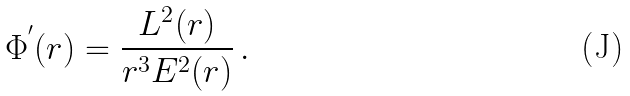<formula> <loc_0><loc_0><loc_500><loc_500>\Phi ^ { ^ { \prime } } ( r ) = \frac { L ^ { 2 } ( r ) } { r ^ { 3 } E ^ { 2 } ( r ) } \, .</formula> 